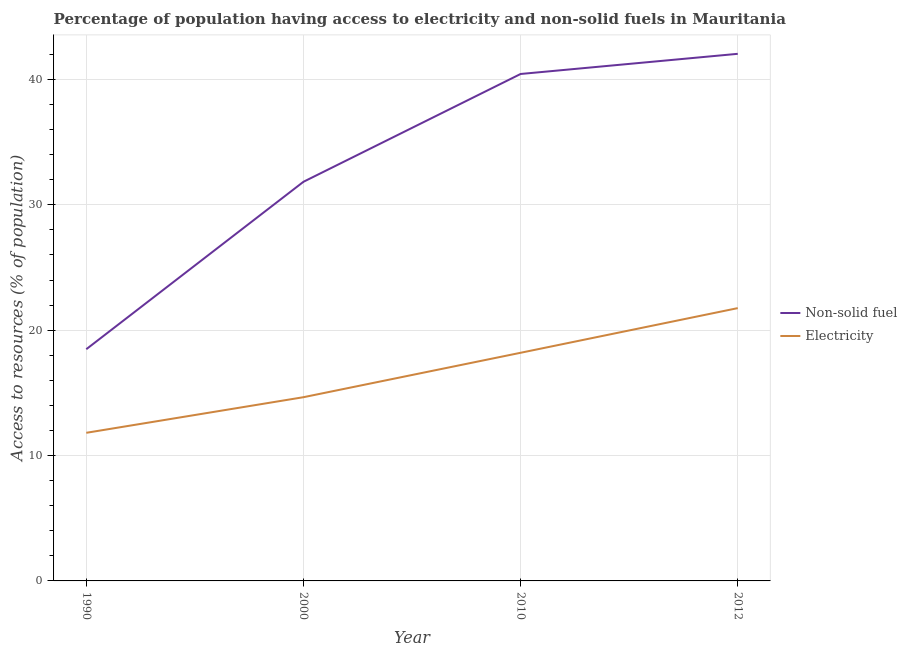Does the line corresponding to percentage of population having access to non-solid fuel intersect with the line corresponding to percentage of population having access to electricity?
Your answer should be very brief. No. What is the percentage of population having access to non-solid fuel in 1990?
Make the answer very short. 18.48. Across all years, what is the maximum percentage of population having access to electricity?
Keep it short and to the point. 21.76. Across all years, what is the minimum percentage of population having access to non-solid fuel?
Make the answer very short. 18.48. In which year was the percentage of population having access to electricity maximum?
Keep it short and to the point. 2012. What is the total percentage of population having access to electricity in the graph?
Give a very brief answer. 66.43. What is the difference between the percentage of population having access to non-solid fuel in 1990 and that in 2010?
Offer a terse response. -21.96. What is the difference between the percentage of population having access to electricity in 2010 and the percentage of population having access to non-solid fuel in 2000?
Provide a short and direct response. -13.64. What is the average percentage of population having access to electricity per year?
Provide a succinct answer. 16.61. In the year 2000, what is the difference between the percentage of population having access to electricity and percentage of population having access to non-solid fuel?
Provide a succinct answer. -17.18. In how many years, is the percentage of population having access to non-solid fuel greater than 34 %?
Your response must be concise. 2. What is the ratio of the percentage of population having access to non-solid fuel in 2000 to that in 2012?
Give a very brief answer. 0.76. Is the percentage of population having access to non-solid fuel in 2000 less than that in 2012?
Make the answer very short. Yes. What is the difference between the highest and the second highest percentage of population having access to non-solid fuel?
Your answer should be very brief. 1.61. What is the difference between the highest and the lowest percentage of population having access to non-solid fuel?
Keep it short and to the point. 23.56. Is the sum of the percentage of population having access to non-solid fuel in 2000 and 2012 greater than the maximum percentage of population having access to electricity across all years?
Keep it short and to the point. Yes. Is the percentage of population having access to non-solid fuel strictly greater than the percentage of population having access to electricity over the years?
Offer a terse response. Yes. What is the difference between two consecutive major ticks on the Y-axis?
Your answer should be compact. 10. Are the values on the major ticks of Y-axis written in scientific E-notation?
Ensure brevity in your answer.  No. Does the graph contain any zero values?
Offer a terse response. No. How are the legend labels stacked?
Provide a succinct answer. Vertical. What is the title of the graph?
Ensure brevity in your answer.  Percentage of population having access to electricity and non-solid fuels in Mauritania. Does "Start a business" appear as one of the legend labels in the graph?
Your response must be concise. No. What is the label or title of the X-axis?
Offer a terse response. Year. What is the label or title of the Y-axis?
Offer a very short reply. Access to resources (% of population). What is the Access to resources (% of population) of Non-solid fuel in 1990?
Provide a succinct answer. 18.48. What is the Access to resources (% of population) in Electricity in 1990?
Give a very brief answer. 11.82. What is the Access to resources (% of population) in Non-solid fuel in 2000?
Your answer should be very brief. 31.84. What is the Access to resources (% of population) of Electricity in 2000?
Give a very brief answer. 14.66. What is the Access to resources (% of population) in Non-solid fuel in 2010?
Offer a very short reply. 40.44. What is the Access to resources (% of population) in Electricity in 2010?
Your response must be concise. 18.2. What is the Access to resources (% of population) of Non-solid fuel in 2012?
Ensure brevity in your answer.  42.05. What is the Access to resources (% of population) of Electricity in 2012?
Provide a succinct answer. 21.76. Across all years, what is the maximum Access to resources (% of population) of Non-solid fuel?
Make the answer very short. 42.05. Across all years, what is the maximum Access to resources (% of population) in Electricity?
Your answer should be very brief. 21.76. Across all years, what is the minimum Access to resources (% of population) of Non-solid fuel?
Your answer should be compact. 18.48. Across all years, what is the minimum Access to resources (% of population) of Electricity?
Keep it short and to the point. 11.82. What is the total Access to resources (% of population) of Non-solid fuel in the graph?
Your answer should be very brief. 132.81. What is the total Access to resources (% of population) in Electricity in the graph?
Your response must be concise. 66.43. What is the difference between the Access to resources (% of population) in Non-solid fuel in 1990 and that in 2000?
Ensure brevity in your answer.  -13.36. What is the difference between the Access to resources (% of population) of Electricity in 1990 and that in 2000?
Your response must be concise. -2.84. What is the difference between the Access to resources (% of population) in Non-solid fuel in 1990 and that in 2010?
Make the answer very short. -21.96. What is the difference between the Access to resources (% of population) in Electricity in 1990 and that in 2010?
Your response must be concise. -6.38. What is the difference between the Access to resources (% of population) of Non-solid fuel in 1990 and that in 2012?
Offer a terse response. -23.56. What is the difference between the Access to resources (% of population) in Electricity in 1990 and that in 2012?
Offer a terse response. -9.95. What is the difference between the Access to resources (% of population) of Non-solid fuel in 2000 and that in 2010?
Offer a terse response. -8.6. What is the difference between the Access to resources (% of population) of Electricity in 2000 and that in 2010?
Keep it short and to the point. -3.54. What is the difference between the Access to resources (% of population) of Non-solid fuel in 2000 and that in 2012?
Your answer should be very brief. -10.21. What is the difference between the Access to resources (% of population) of Electricity in 2000 and that in 2012?
Provide a short and direct response. -7.11. What is the difference between the Access to resources (% of population) of Non-solid fuel in 2010 and that in 2012?
Keep it short and to the point. -1.61. What is the difference between the Access to resources (% of population) of Electricity in 2010 and that in 2012?
Offer a terse response. -3.56. What is the difference between the Access to resources (% of population) in Non-solid fuel in 1990 and the Access to resources (% of population) in Electricity in 2000?
Keep it short and to the point. 3.83. What is the difference between the Access to resources (% of population) in Non-solid fuel in 1990 and the Access to resources (% of population) in Electricity in 2010?
Make the answer very short. 0.28. What is the difference between the Access to resources (% of population) in Non-solid fuel in 1990 and the Access to resources (% of population) in Electricity in 2012?
Provide a succinct answer. -3.28. What is the difference between the Access to resources (% of population) in Non-solid fuel in 2000 and the Access to resources (% of population) in Electricity in 2010?
Keep it short and to the point. 13.64. What is the difference between the Access to resources (% of population) in Non-solid fuel in 2000 and the Access to resources (% of population) in Electricity in 2012?
Provide a succinct answer. 10.08. What is the difference between the Access to resources (% of population) of Non-solid fuel in 2010 and the Access to resources (% of population) of Electricity in 2012?
Ensure brevity in your answer.  18.68. What is the average Access to resources (% of population) in Non-solid fuel per year?
Offer a very short reply. 33.2. What is the average Access to resources (% of population) of Electricity per year?
Your response must be concise. 16.61. In the year 1990, what is the difference between the Access to resources (% of population) in Non-solid fuel and Access to resources (% of population) in Electricity?
Your answer should be very brief. 6.67. In the year 2000, what is the difference between the Access to resources (% of population) in Non-solid fuel and Access to resources (% of population) in Electricity?
Give a very brief answer. 17.18. In the year 2010, what is the difference between the Access to resources (% of population) of Non-solid fuel and Access to resources (% of population) of Electricity?
Keep it short and to the point. 22.24. In the year 2012, what is the difference between the Access to resources (% of population) in Non-solid fuel and Access to resources (% of population) in Electricity?
Keep it short and to the point. 20.29. What is the ratio of the Access to resources (% of population) in Non-solid fuel in 1990 to that in 2000?
Make the answer very short. 0.58. What is the ratio of the Access to resources (% of population) in Electricity in 1990 to that in 2000?
Provide a succinct answer. 0.81. What is the ratio of the Access to resources (% of population) of Non-solid fuel in 1990 to that in 2010?
Keep it short and to the point. 0.46. What is the ratio of the Access to resources (% of population) in Electricity in 1990 to that in 2010?
Your answer should be compact. 0.65. What is the ratio of the Access to resources (% of population) in Non-solid fuel in 1990 to that in 2012?
Provide a succinct answer. 0.44. What is the ratio of the Access to resources (% of population) of Electricity in 1990 to that in 2012?
Offer a very short reply. 0.54. What is the ratio of the Access to resources (% of population) of Non-solid fuel in 2000 to that in 2010?
Offer a very short reply. 0.79. What is the ratio of the Access to resources (% of population) in Electricity in 2000 to that in 2010?
Provide a short and direct response. 0.81. What is the ratio of the Access to resources (% of population) of Non-solid fuel in 2000 to that in 2012?
Ensure brevity in your answer.  0.76. What is the ratio of the Access to resources (% of population) of Electricity in 2000 to that in 2012?
Your response must be concise. 0.67. What is the ratio of the Access to resources (% of population) in Non-solid fuel in 2010 to that in 2012?
Ensure brevity in your answer.  0.96. What is the ratio of the Access to resources (% of population) in Electricity in 2010 to that in 2012?
Keep it short and to the point. 0.84. What is the difference between the highest and the second highest Access to resources (% of population) of Non-solid fuel?
Your answer should be compact. 1.61. What is the difference between the highest and the second highest Access to resources (% of population) of Electricity?
Make the answer very short. 3.56. What is the difference between the highest and the lowest Access to resources (% of population) in Non-solid fuel?
Your answer should be very brief. 23.56. What is the difference between the highest and the lowest Access to resources (% of population) of Electricity?
Offer a very short reply. 9.95. 